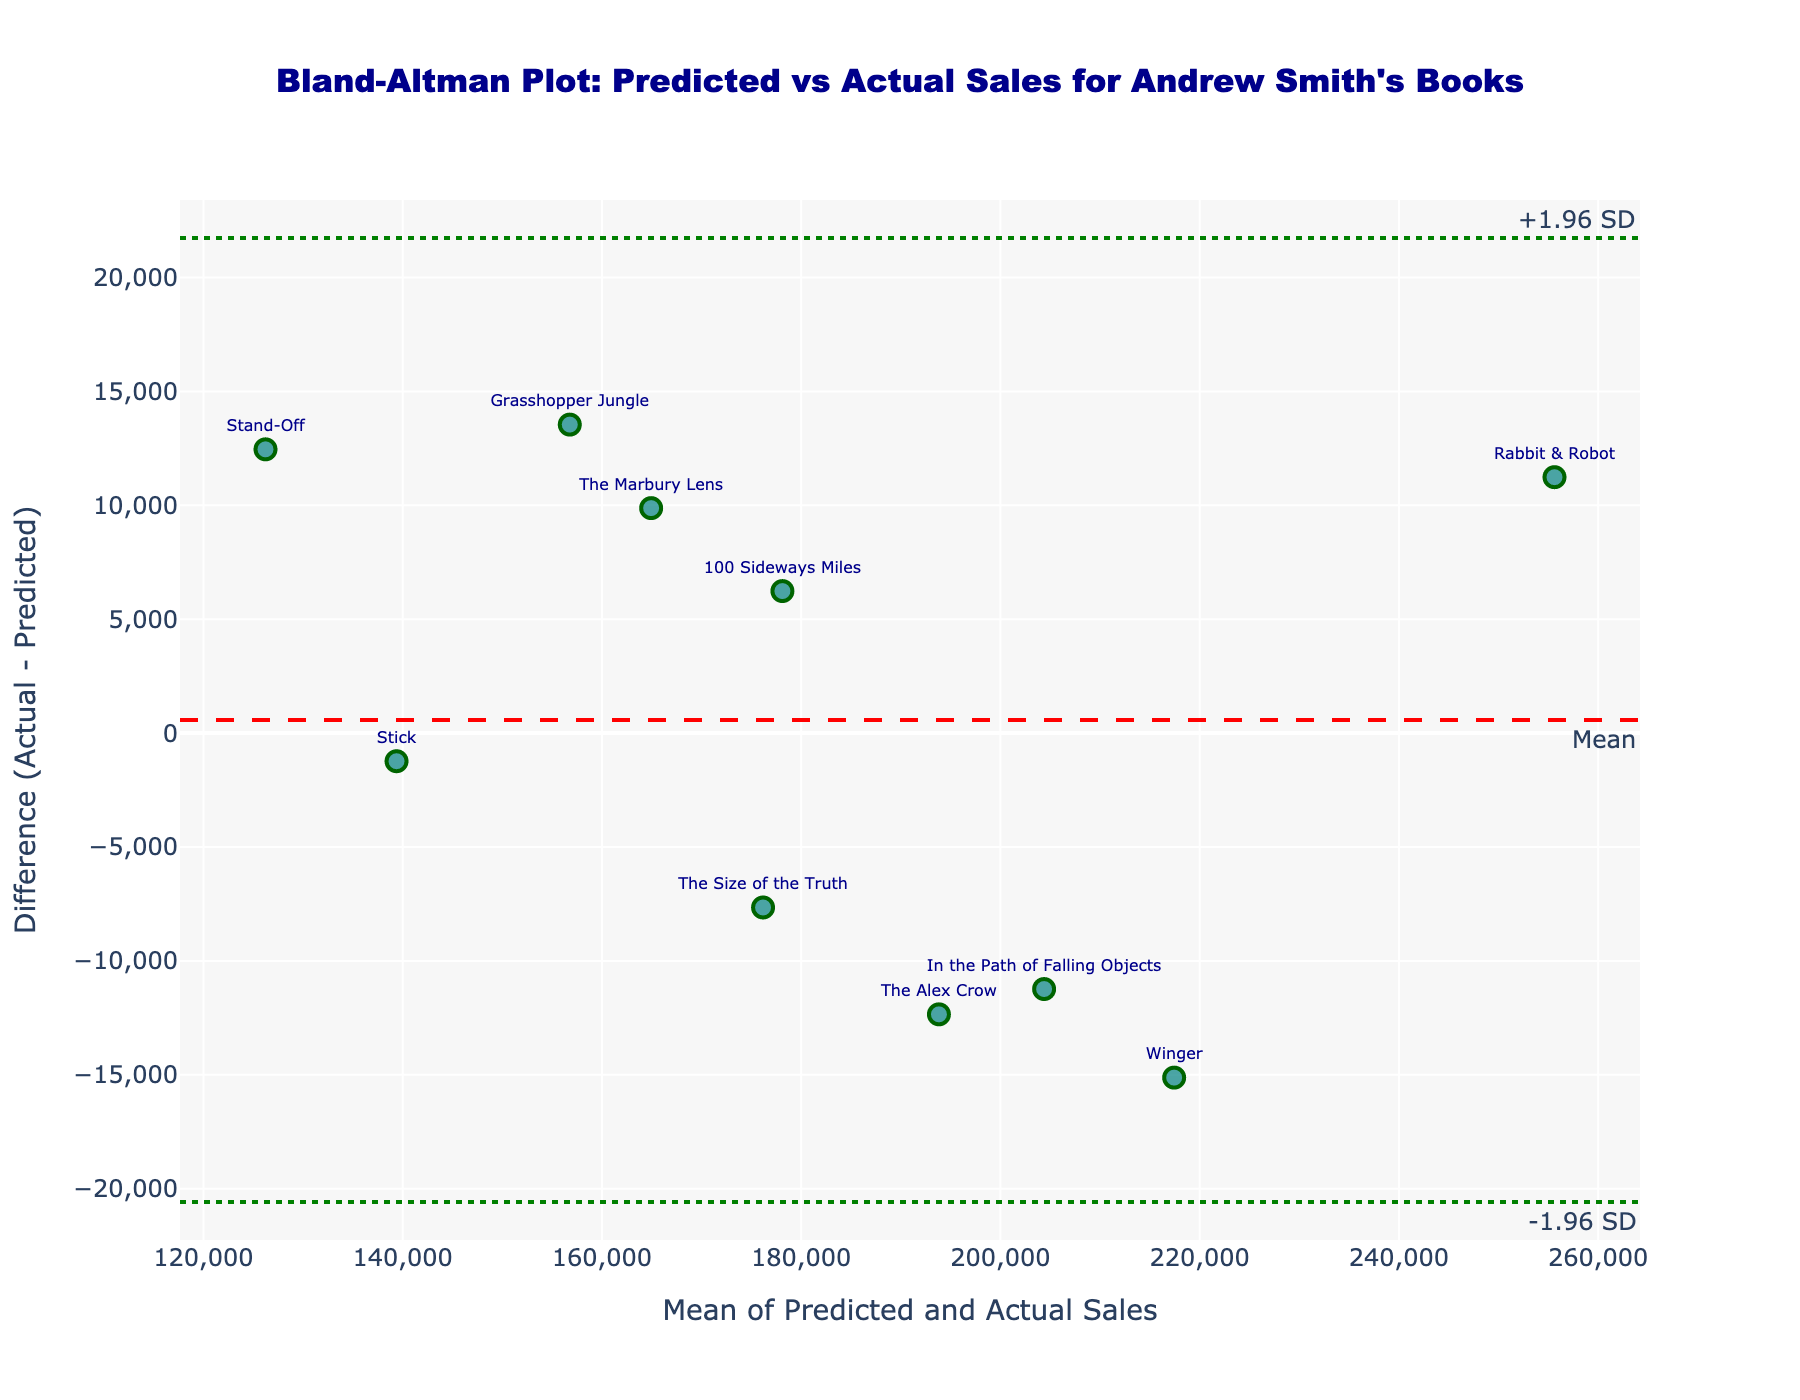What's the title of the figure? The title of the figure is usually located at the top of the graph. In this case, it's written in a larger, bold font.
Answer: Bland-Altman Plot: Predicted vs Actual Sales for Andrew Smith's Books What does the x-axis represent? The x-axis title can be found at the bottom of the figure and provides information about what is plotted on this axis.
Answer: Mean of Predicted and Actual Sales What does the y-axis represent? The y-axis title is located on the left side of the figure and indicates what is plotted on the vertical axis.
Answer: Difference (Actual - Predicted) How many books are visualized in this plot? By counting the number of data points (markers) labeled with book titles on the figure, you can determine the total.
Answer: 10 What is the book with the largest positive difference between actual and predicted sales? Look for the data point furthest above the x-axis with the largest positive difference value. Hover text shows details about each point.
Answer: Grasshopper Jungle Which book had actual sales closest to the predicted sales? Find the data point that is closest to the zero mark on the y-axis, as it represents the least difference between actual and predicted sales. Hover text provides detailed sales figures.
Answer: Stick What is the mean difference between actual and predicted sales? The mean difference can be identified by the horizontal line labeled "Mean" which is drawn across the plot.
Answer: ~ -1559 What books are outside the ±1.96 SD limits? Identify data points lying beyond the dotted lines depicting ±1.96 SD. These lines are labeled "+1.96 SD" and "-1.96 SD".
Answer: Grasshopper Jungle, Rabbit & Robot Based on this plot, which book had the highest mean sales (predicted + actual / 2)? Locate the data point farthest to the right along the x-axis to identify the book with the highest mean sales. Hover text provides detailed sales figures.
Answer: Rabbit & Robot 